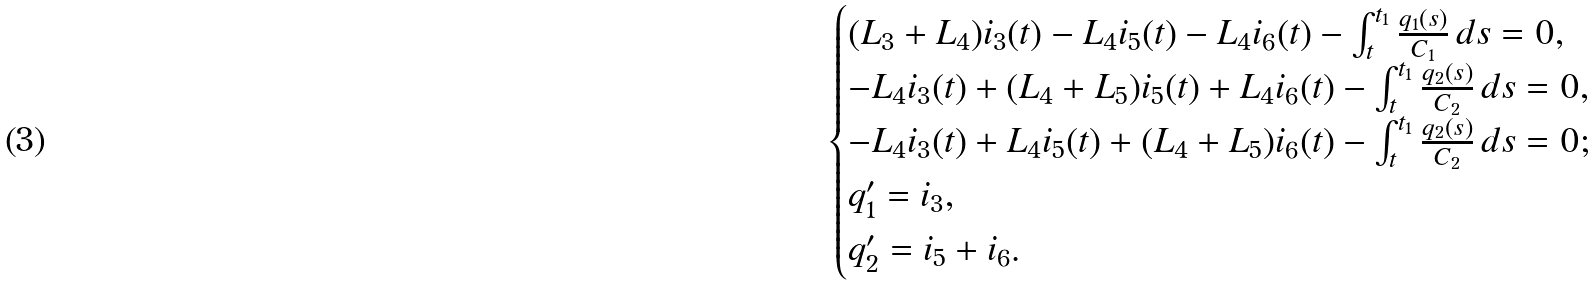<formula> <loc_0><loc_0><loc_500><loc_500>\begin{cases} ( L _ { 3 } + L _ { 4 } ) i _ { 3 } ( t ) - L _ { 4 } i _ { 5 } ( t ) - L _ { 4 } i _ { 6 } ( t ) - \int _ { t } ^ { t _ { 1 } } \frac { q _ { 1 } ( s ) } { C _ { 1 } } \, d s = 0 , \\ - L _ { 4 } i _ { 3 } ( t ) + ( L _ { 4 } + L _ { 5 } ) i _ { 5 } ( t ) + L _ { 4 } i _ { 6 } ( t ) - \int _ { t } ^ { t _ { 1 } } \frac { q _ { 2 } ( s ) } { C _ { 2 } } \, d s = 0 , \\ - L _ { 4 } i _ { 3 } ( t ) + L _ { 4 } i _ { 5 } ( t ) + ( L _ { 4 } + L _ { 5 } ) i _ { 6 } ( t ) - \int _ { t } ^ { t _ { 1 } } \frac { q _ { 2 } ( s ) } { C _ { 2 } } \, d s = 0 ; \\ q _ { 1 } ^ { \prime } = i _ { 3 } , \\ q _ { 2 } ^ { \prime } = i _ { 5 } + i _ { 6 } . \end{cases}</formula> 